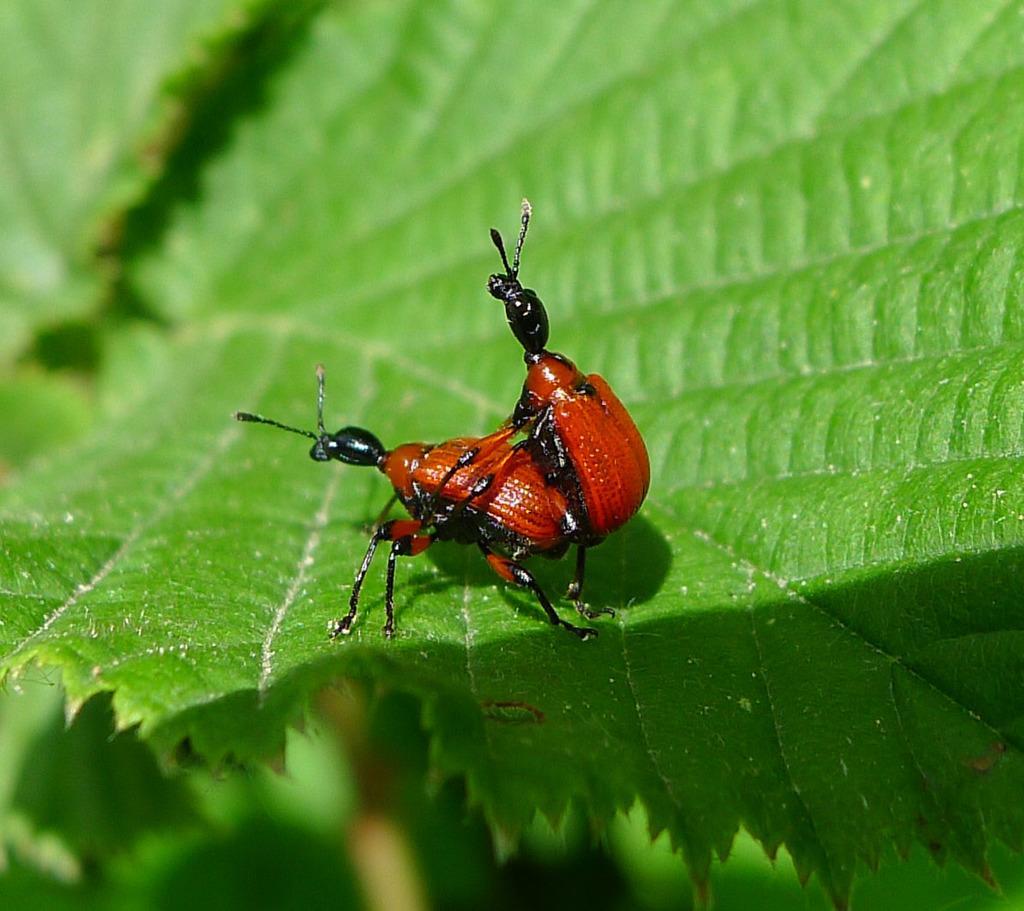Can you describe this image briefly? In the image there are two insects on a leaf. 